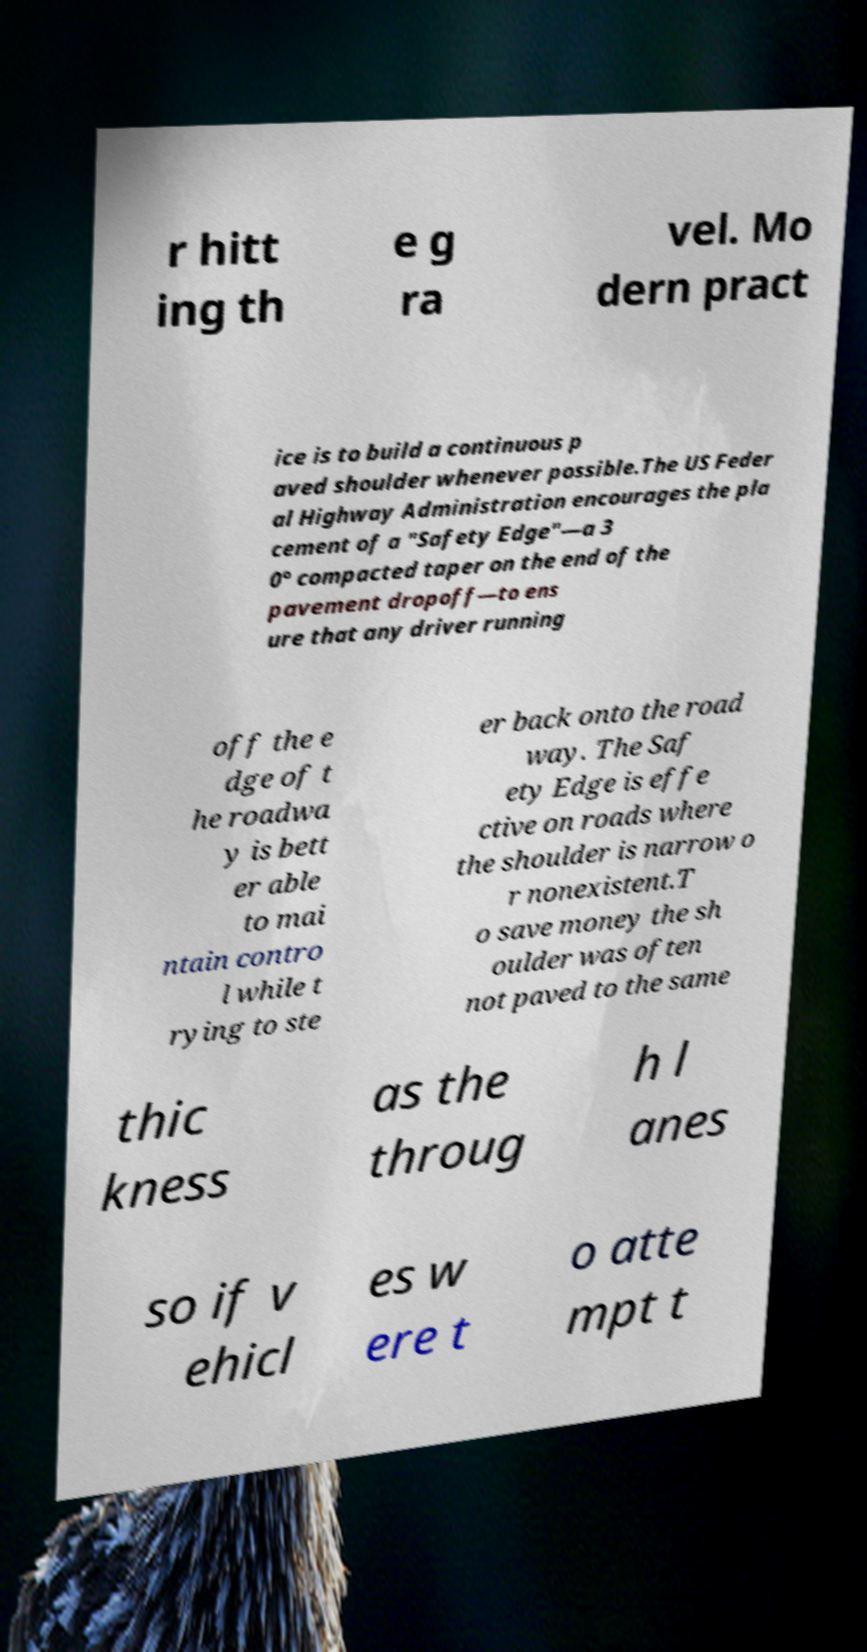Please identify and transcribe the text found in this image. r hitt ing th e g ra vel. Mo dern pract ice is to build a continuous p aved shoulder whenever possible.The US Feder al Highway Administration encourages the pla cement of a "Safety Edge"—a 3 0° compacted taper on the end of the pavement dropoff—to ens ure that any driver running off the e dge of t he roadwa y is bett er able to mai ntain contro l while t rying to ste er back onto the road way. The Saf ety Edge is effe ctive on roads where the shoulder is narrow o r nonexistent.T o save money the sh oulder was often not paved to the same thic kness as the throug h l anes so if v ehicl es w ere t o atte mpt t 